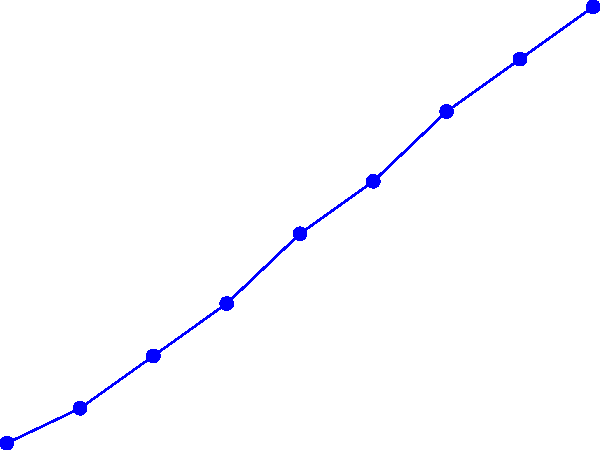As a sports camp organizer, you're analyzing the effectiveness of different training regimens on athlete performance. The graph shows the performance scores of three groups following different training intensities over 8 weeks. Which training regimen shows the most consistent improvement, and what might this suggest about its effectiveness for long-term athlete development? To answer this question, we need to analyze the three lines representing different training intensities:

1. Blue line (High-Intensity): Shows rapid improvement initially but starts to plateau towards the end.
2. Red line (Mixed): Shows steady improvement throughout the 8 weeks.
3. Green line (Low-Intensity): Shows slow but consistent improvement.

To determine the most consistent improvement, we need to look at the slope of each line:

1. High-Intensity: Slope varies, steep at first then flattens.
2. Mixed: Slope remains relatively constant throughout.
3. Low-Intensity: Slope is constant but less steep than the others.

The Mixed intensity regimen (red line) shows the most consistent improvement as its slope remains relatively constant throughout the 8 weeks.

This suggests that a mixed intensity training regimen might be more effective for long-term athlete development because:

1. It provides a balance between high and low-intensity workouts.
2. It allows for consistent progress without early plateaus.
3. It may reduce the risk of burnout or injury associated with constant high-intensity training.
4. It could be more sustainable for athletes over extended periods.

For a sports camp organizer, this information is valuable when designing training programs and connecting coaches with athletes, as it emphasizes the importance of balanced, sustainable training approaches for long-term development.
Answer: Mixed intensity regimen; balanced approach for sustainable long-term development. 